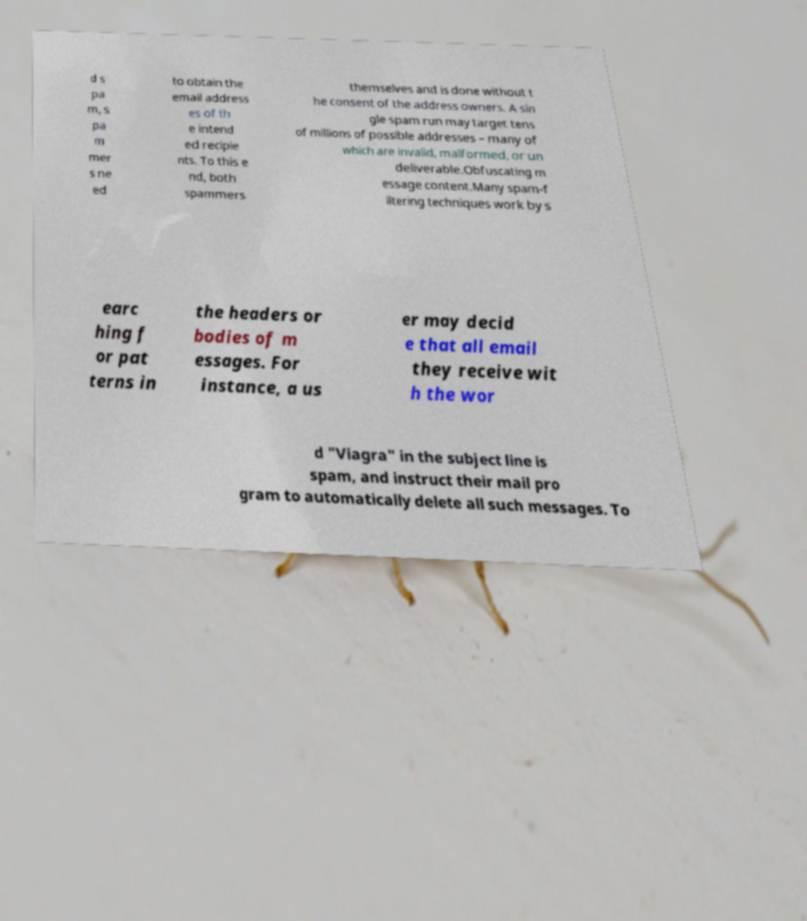What messages or text are displayed in this image? I need them in a readable, typed format. d s pa m, s pa m mer s ne ed to obtain the email address es of th e intend ed recipie nts. To this e nd, both spammers themselves and is done without t he consent of the address owners. A sin gle spam run may target tens of millions of possible addresses – many of which are invalid, malformed, or un deliverable.Obfuscating m essage content.Many spam-f iltering techniques work by s earc hing f or pat terns in the headers or bodies of m essages. For instance, a us er may decid e that all email they receive wit h the wor d "Viagra" in the subject line is spam, and instruct their mail pro gram to automatically delete all such messages. To 